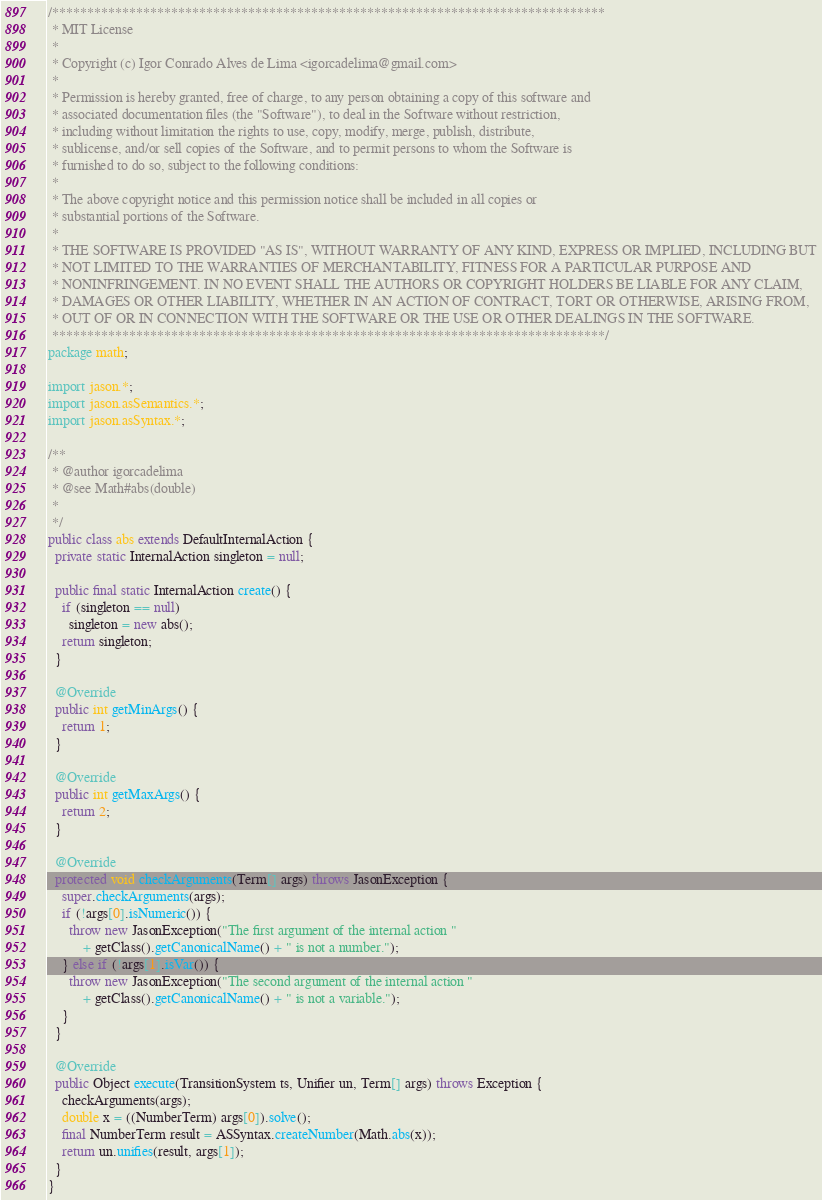<code> <loc_0><loc_0><loc_500><loc_500><_Java_>/*******************************************************************************
 * MIT License
 *
 * Copyright (c) Igor Conrado Alves de Lima <igorcadelima@gmail.com>
 *
 * Permission is hereby granted, free of charge, to any person obtaining a copy of this software and
 * associated documentation files (the "Software"), to deal in the Software without restriction,
 * including without limitation the rights to use, copy, modify, merge, publish, distribute,
 * sublicense, and/or sell copies of the Software, and to permit persons to whom the Software is
 * furnished to do so, subject to the following conditions:
 *
 * The above copyright notice and this permission notice shall be included in all copies or
 * substantial portions of the Software.
 *
 * THE SOFTWARE IS PROVIDED "AS IS", WITHOUT WARRANTY OF ANY KIND, EXPRESS OR IMPLIED, INCLUDING BUT
 * NOT LIMITED TO THE WARRANTIES OF MERCHANTABILITY, FITNESS FOR A PARTICULAR PURPOSE AND
 * NONINFRINGEMENT. IN NO EVENT SHALL THE AUTHORS OR COPYRIGHT HOLDERS BE LIABLE FOR ANY CLAIM,
 * DAMAGES OR OTHER LIABILITY, WHETHER IN AN ACTION OF CONTRACT, TORT OR OTHERWISE, ARISING FROM,
 * OUT OF OR IN CONNECTION WITH THE SOFTWARE OR THE USE OR OTHER DEALINGS IN THE SOFTWARE.
 *******************************************************************************/
package math;

import jason.*;
import jason.asSemantics.*;
import jason.asSyntax.*;

/**
 * @author igorcadelima
 * @see Math#abs(double)
 *
 */
public class abs extends DefaultInternalAction {
  private static InternalAction singleton = null;

  public final static InternalAction create() {
    if (singleton == null)
      singleton = new abs();
    return singleton;
  }

  @Override
  public int getMinArgs() {
    return 1;
  }

  @Override
  public int getMaxArgs() {
    return 2;
  }

  @Override
  protected void checkArguments(Term[] args) throws JasonException {
    super.checkArguments(args);
    if (!args[0].isNumeric()) {
      throw new JasonException("The first argument of the internal action "
          + getClass().getCanonicalName() + " is not a number.");
    } else if (!args[1].isVar()) {
      throw new JasonException("The second argument of the internal action "
          + getClass().getCanonicalName() + " is not a variable.");
    }
  }

  @Override
  public Object execute(TransitionSystem ts, Unifier un, Term[] args) throws Exception {
    checkArguments(args);
    double x = ((NumberTerm) args[0]).solve();
    final NumberTerm result = ASSyntax.createNumber(Math.abs(x));
    return un.unifies(result, args[1]);
  }
}
</code> 